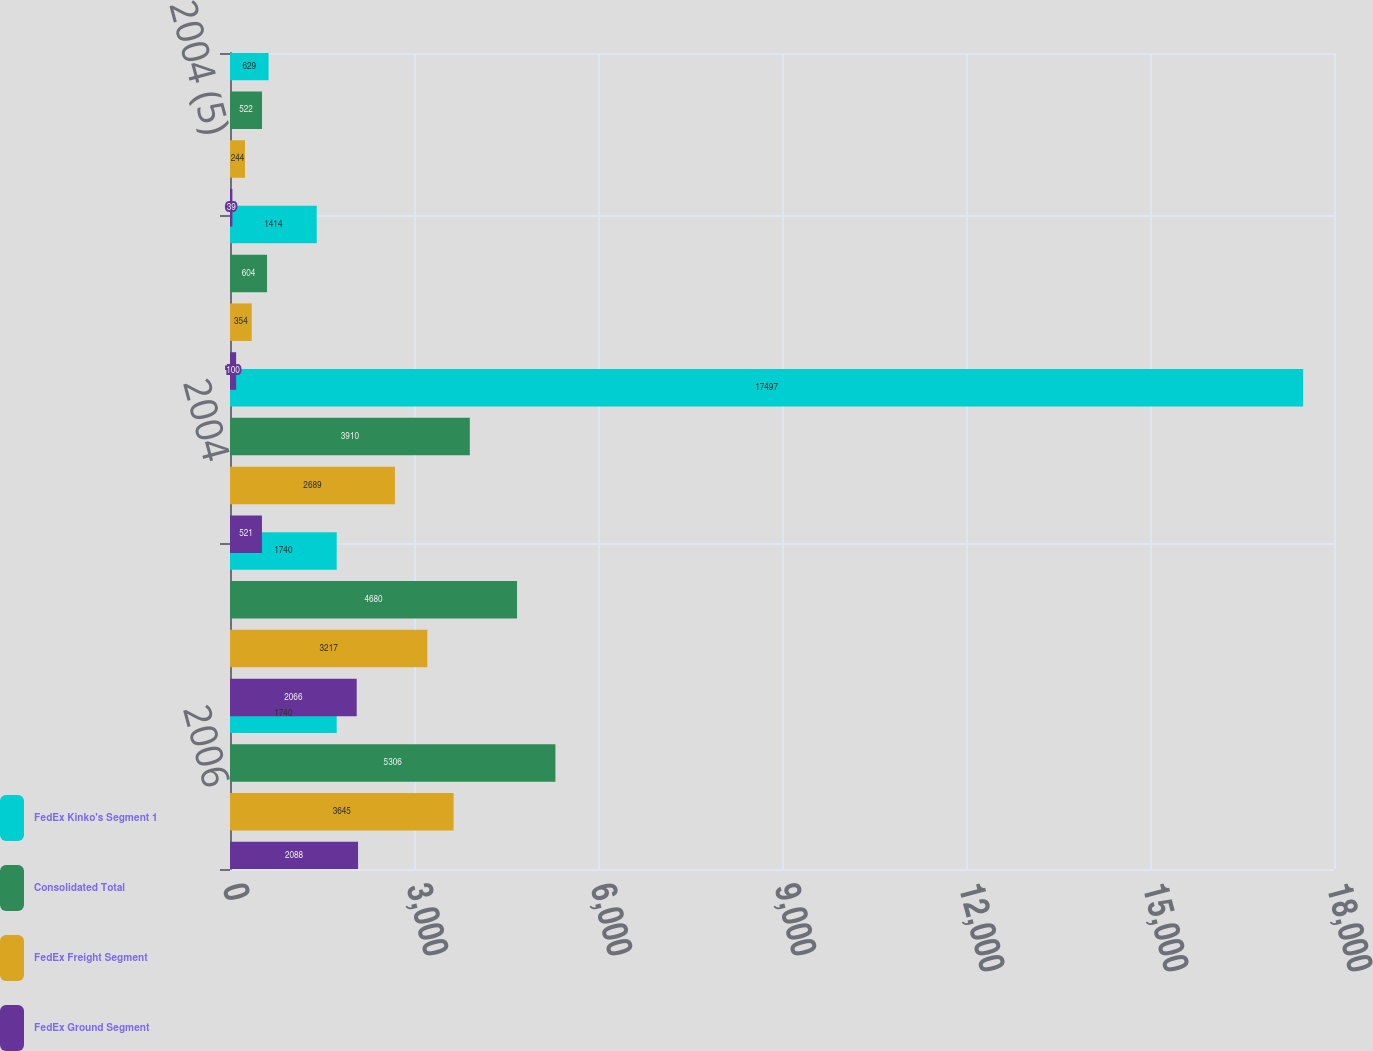Convert chart to OTSL. <chart><loc_0><loc_0><loc_500><loc_500><stacked_bar_chart><ecel><fcel>2006<fcel>2005<fcel>2004<fcel>2005 (4)<fcel>2004 (5)<nl><fcel>FedEx Kinko's Segment 1<fcel>1740<fcel>1740<fcel>17497<fcel>1414<fcel>629<nl><fcel>Consolidated Total<fcel>5306<fcel>4680<fcel>3910<fcel>604<fcel>522<nl><fcel>FedEx Freight Segment<fcel>3645<fcel>3217<fcel>2689<fcel>354<fcel>244<nl><fcel>FedEx Ground Segment<fcel>2088<fcel>2066<fcel>521<fcel>100<fcel>39<nl></chart> 